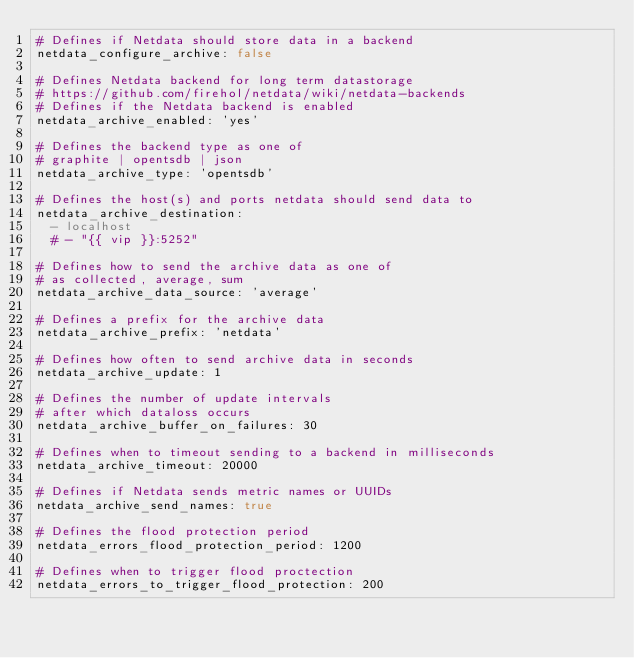Convert code to text. <code><loc_0><loc_0><loc_500><loc_500><_YAML_># Defines if Netdata should store data in a backend
netdata_configure_archive: false

# Defines Netdata backend for long term datastorage
# https://github.com/firehol/netdata/wiki/netdata-backends
# Defines if the Netdata backend is enabled
netdata_archive_enabled: 'yes'

# Defines the backend type as one of
# graphite | opentsdb | json
netdata_archive_type: 'opentsdb'

# Defines the host(s) and ports netdata should send data to
netdata_archive_destination:
  - localhost
  # - "{{ vip }}:5252"

# Defines how to send the archive data as one of
# as collected, average, sum
netdata_archive_data_source: 'average'

# Defines a prefix for the archive data
netdata_archive_prefix: 'netdata'

# Defines how often to send archive data in seconds
netdata_archive_update: 1

# Defines the number of update intervals
# after which dataloss occurs
netdata_archive_buffer_on_failures: 30

# Defines when to timeout sending to a backend in milliseconds
netdata_archive_timeout: 20000

# Defines if Netdata sends metric names or UUIDs
netdata_archive_send_names: true

# Defines the flood protection period
netdata_errors_flood_protection_period: 1200

# Defines when to trigger flood proctection
netdata_errors_to_trigger_flood_protection: 200
</code> 